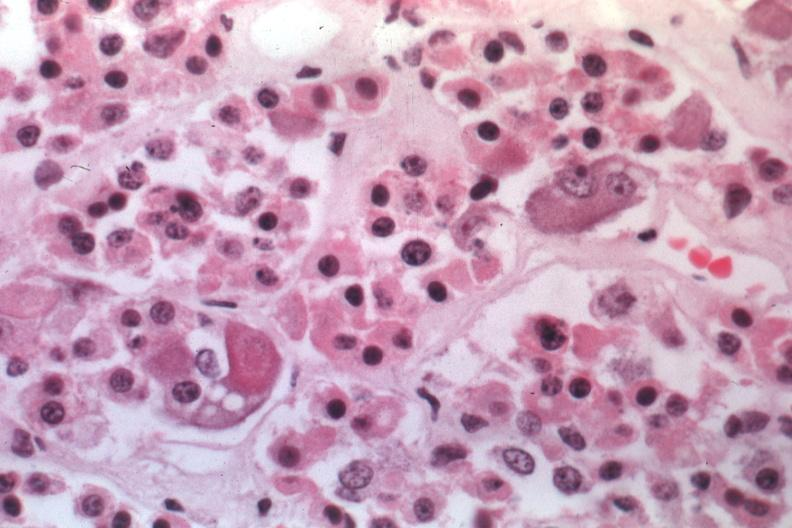what is present?
Answer the question using a single word or phrase. Crookes cells 